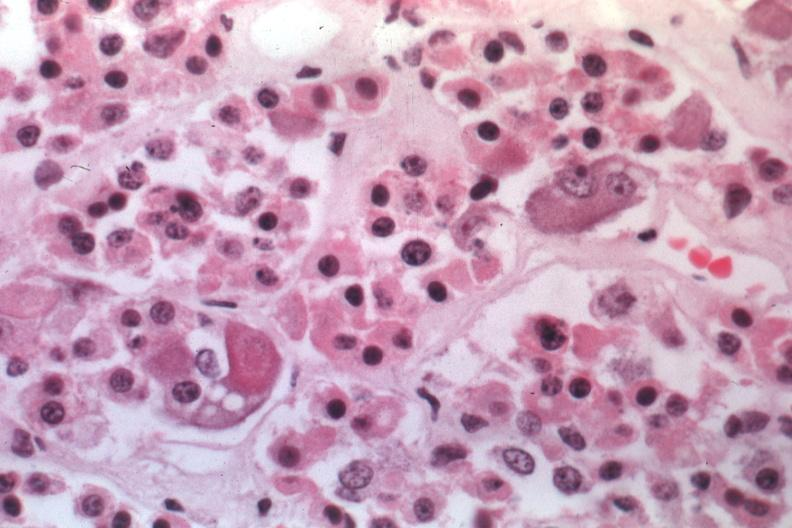what is present?
Answer the question using a single word or phrase. Crookes cells 